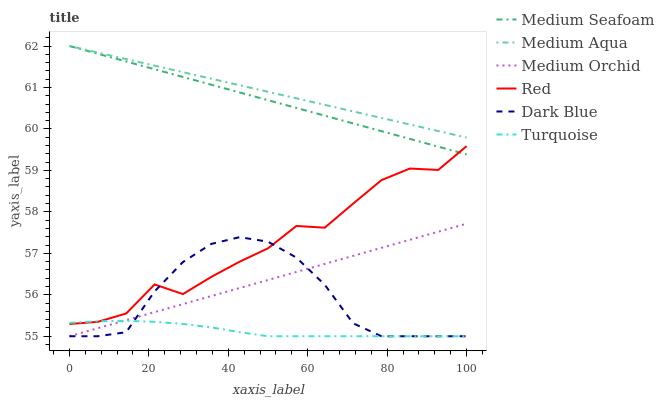Does Turquoise have the minimum area under the curve?
Answer yes or no. Yes. Does Medium Aqua have the maximum area under the curve?
Answer yes or no. Yes. Does Medium Orchid have the minimum area under the curve?
Answer yes or no. No. Does Medium Orchid have the maximum area under the curve?
Answer yes or no. No. Is Medium Seafoam the smoothest?
Answer yes or no. Yes. Is Red the roughest?
Answer yes or no. Yes. Is Medium Orchid the smoothest?
Answer yes or no. No. Is Medium Orchid the roughest?
Answer yes or no. No. Does Turquoise have the lowest value?
Answer yes or no. Yes. Does Medium Aqua have the lowest value?
Answer yes or no. No. Does Medium Seafoam have the highest value?
Answer yes or no. Yes. Does Medium Orchid have the highest value?
Answer yes or no. No. Is Medium Orchid less than Medium Aqua?
Answer yes or no. Yes. Is Medium Seafoam greater than Turquoise?
Answer yes or no. Yes. Does Dark Blue intersect Medium Orchid?
Answer yes or no. Yes. Is Dark Blue less than Medium Orchid?
Answer yes or no. No. Is Dark Blue greater than Medium Orchid?
Answer yes or no. No. Does Medium Orchid intersect Medium Aqua?
Answer yes or no. No. 